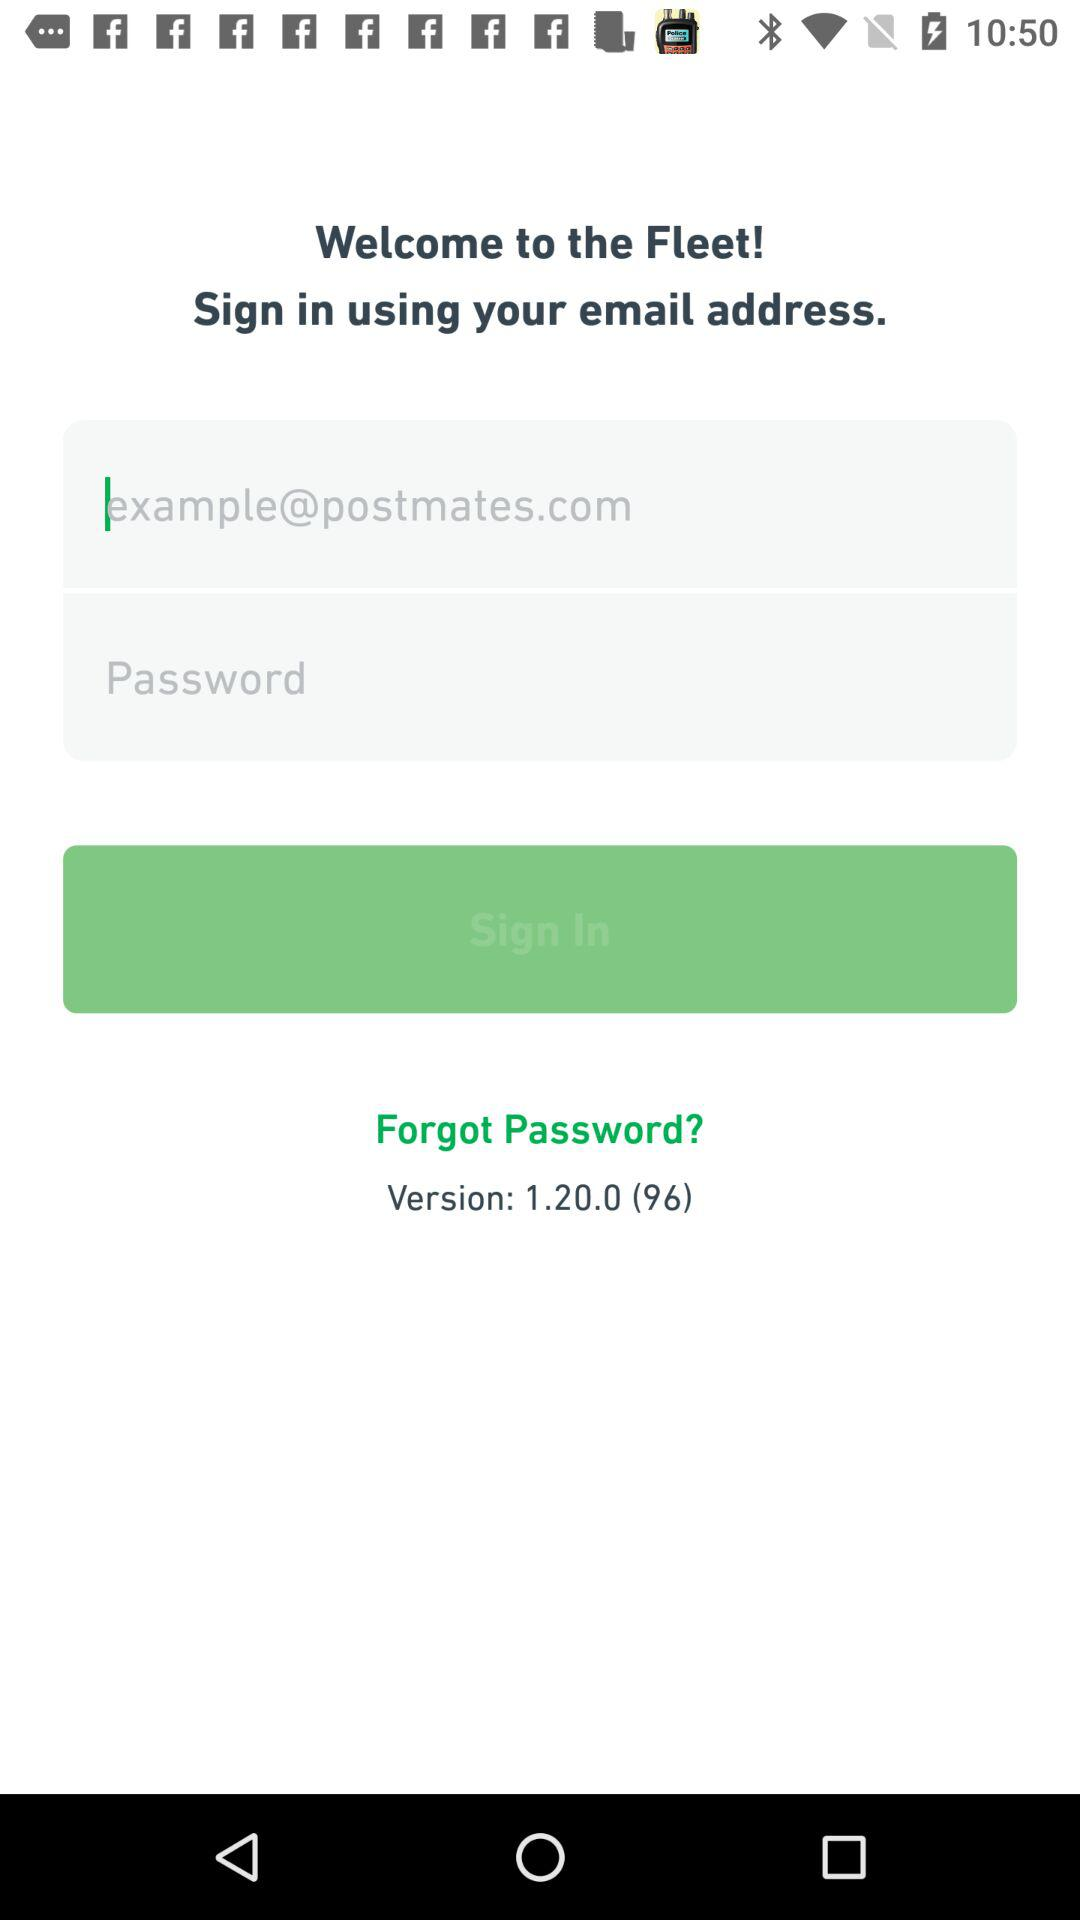What is the name of the application? The name of the application is "Fleet". 